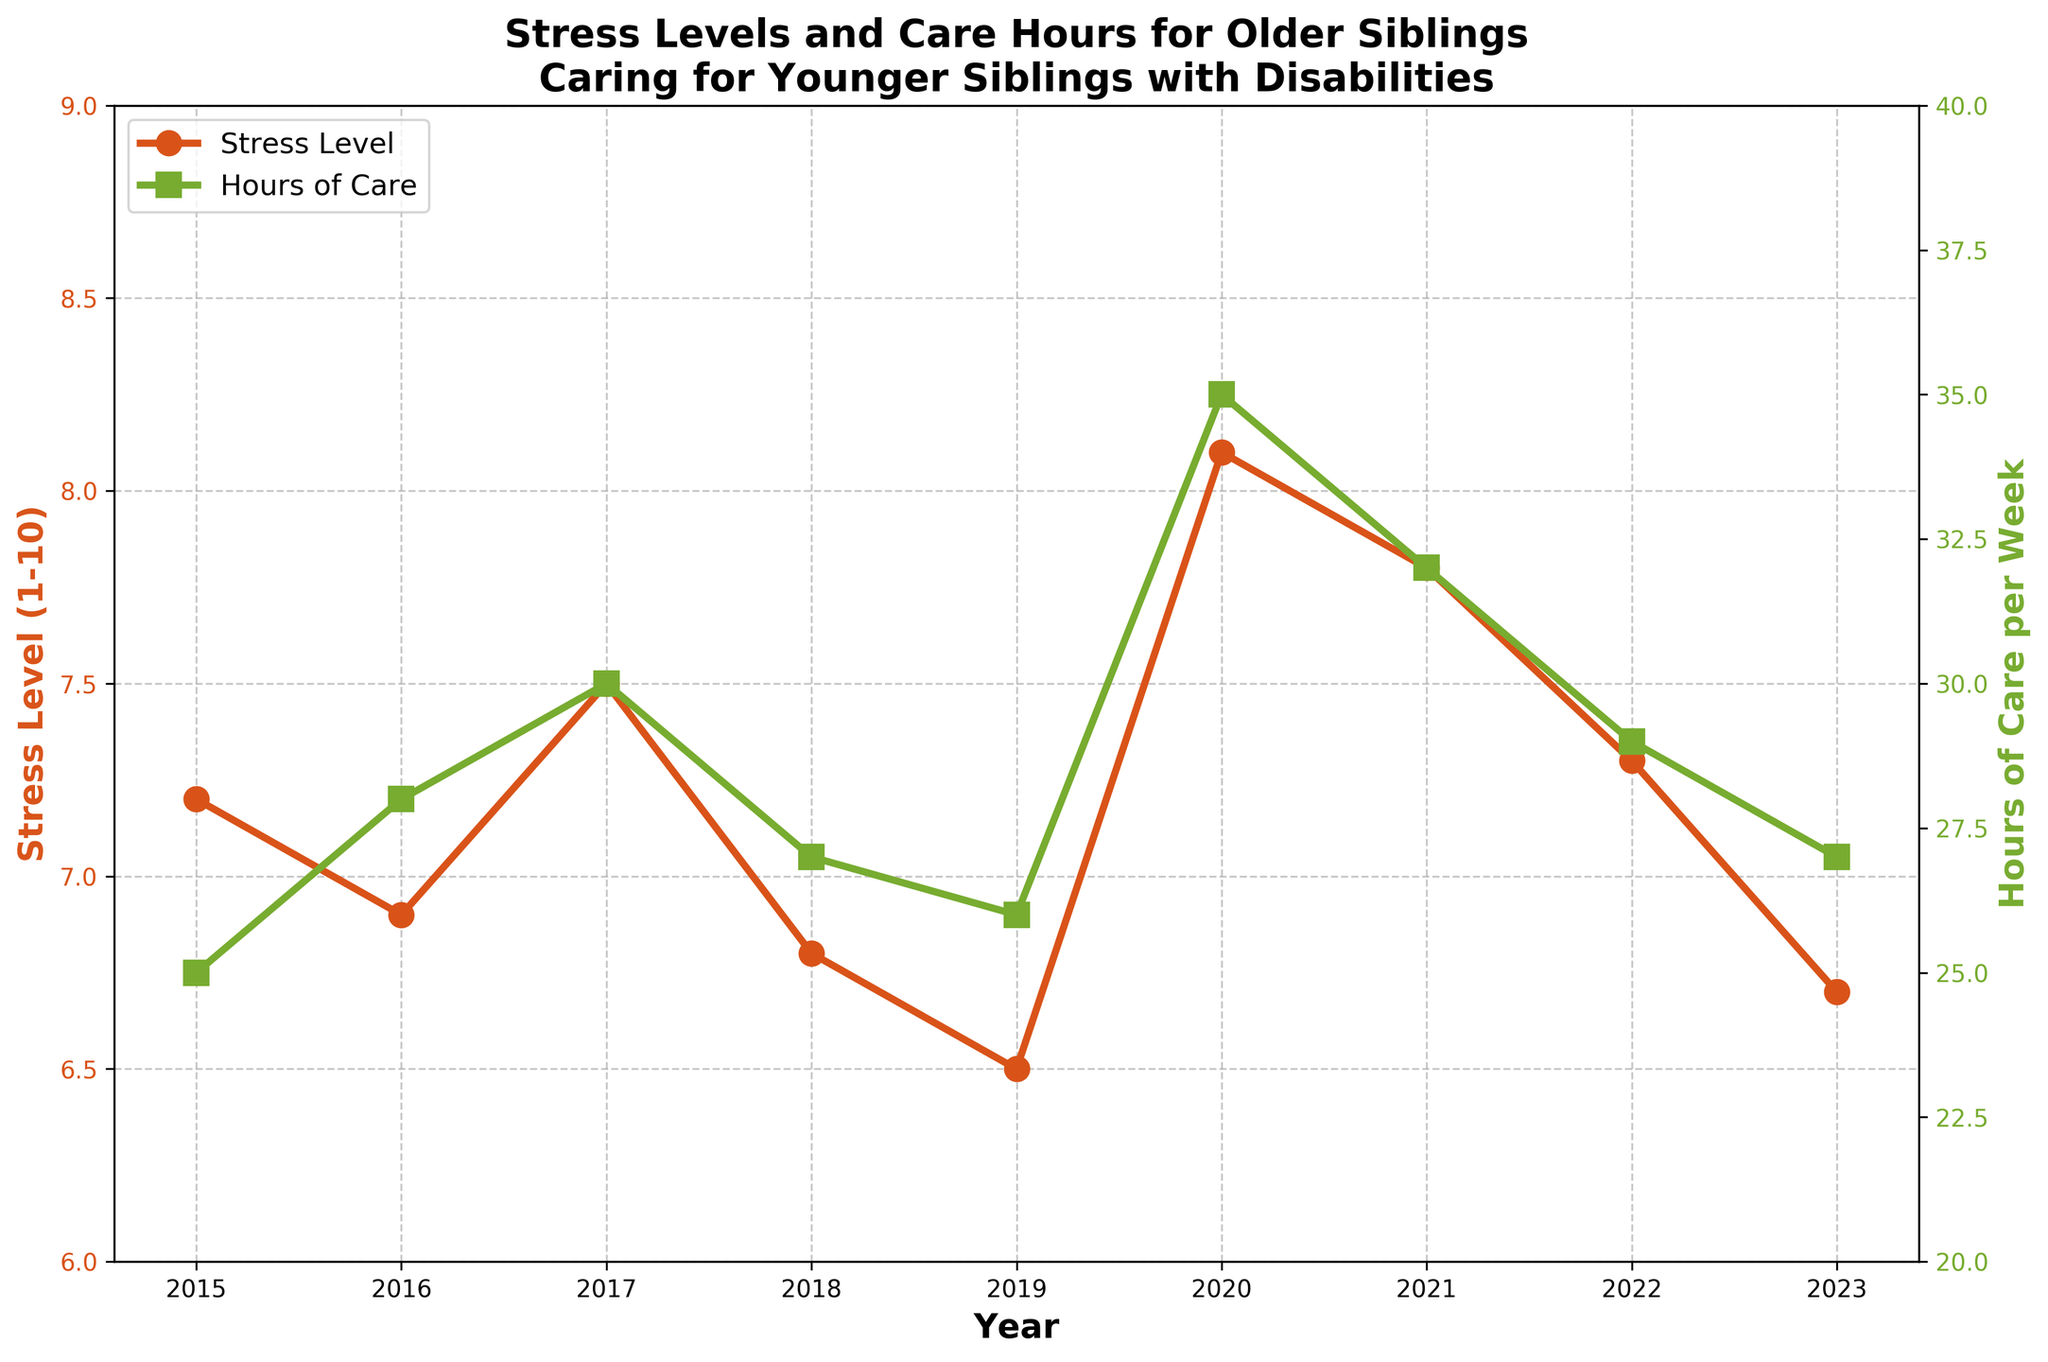Which year had the highest stress level? The stress level is represented by the red line. The highest point on the red line occurs in 2020.
Answer: 2020 In which year were the hours of care the highest? The hours of care are represented by the green line. The highest point on the green line occurs in 2020.
Answer: 2020 What is the difference in stress levels between 2019 and 2020? The stress level in 2019 is 6.5 and in 2020 is 8.1. The difference is 8.1 - 6.5.
Answer: 1.6 Compare the stress levels in 2016 and 2023, which is higher? The stress level in 2016 is 6.9 and in 2023 is 6.7. Therefore, 2016 is higher.
Answer: 2016 How many years had a stress level greater than 7? The red line (stress levels) is above 7 in 2015, 2017, 2020, and 2021. That's 4 years.
Answer: 4 In which years were the hours of care per week higher than 30? The green line (hours of care) is above 30 in 2017, 2020, and 2021.
Answer: 2017, 2020, 2021 What is the average stress level from 2015 to 2023? Sum of stress levels from 2015 to 2023 is (7.2 + 6.9 + 7.5 + 6.8 + 6.5 + 8.1 + 7.8 + 7.3 + 6.7) = 64.8. There are 9 years, so the average stress level is 64.8 / 9.
Answer: 7.2 Which year had the lowest stress level? The red line (stress level) reaches its lowest point in 2023.
Answer: 2023 Is there a visual correlation between the stress levels and hours of care per week? By observing the patterns in the red and green lines, it appears that higher hours of care often coincide with higher stress levels, particularly noticeable in 2020.
Answer: Yes 